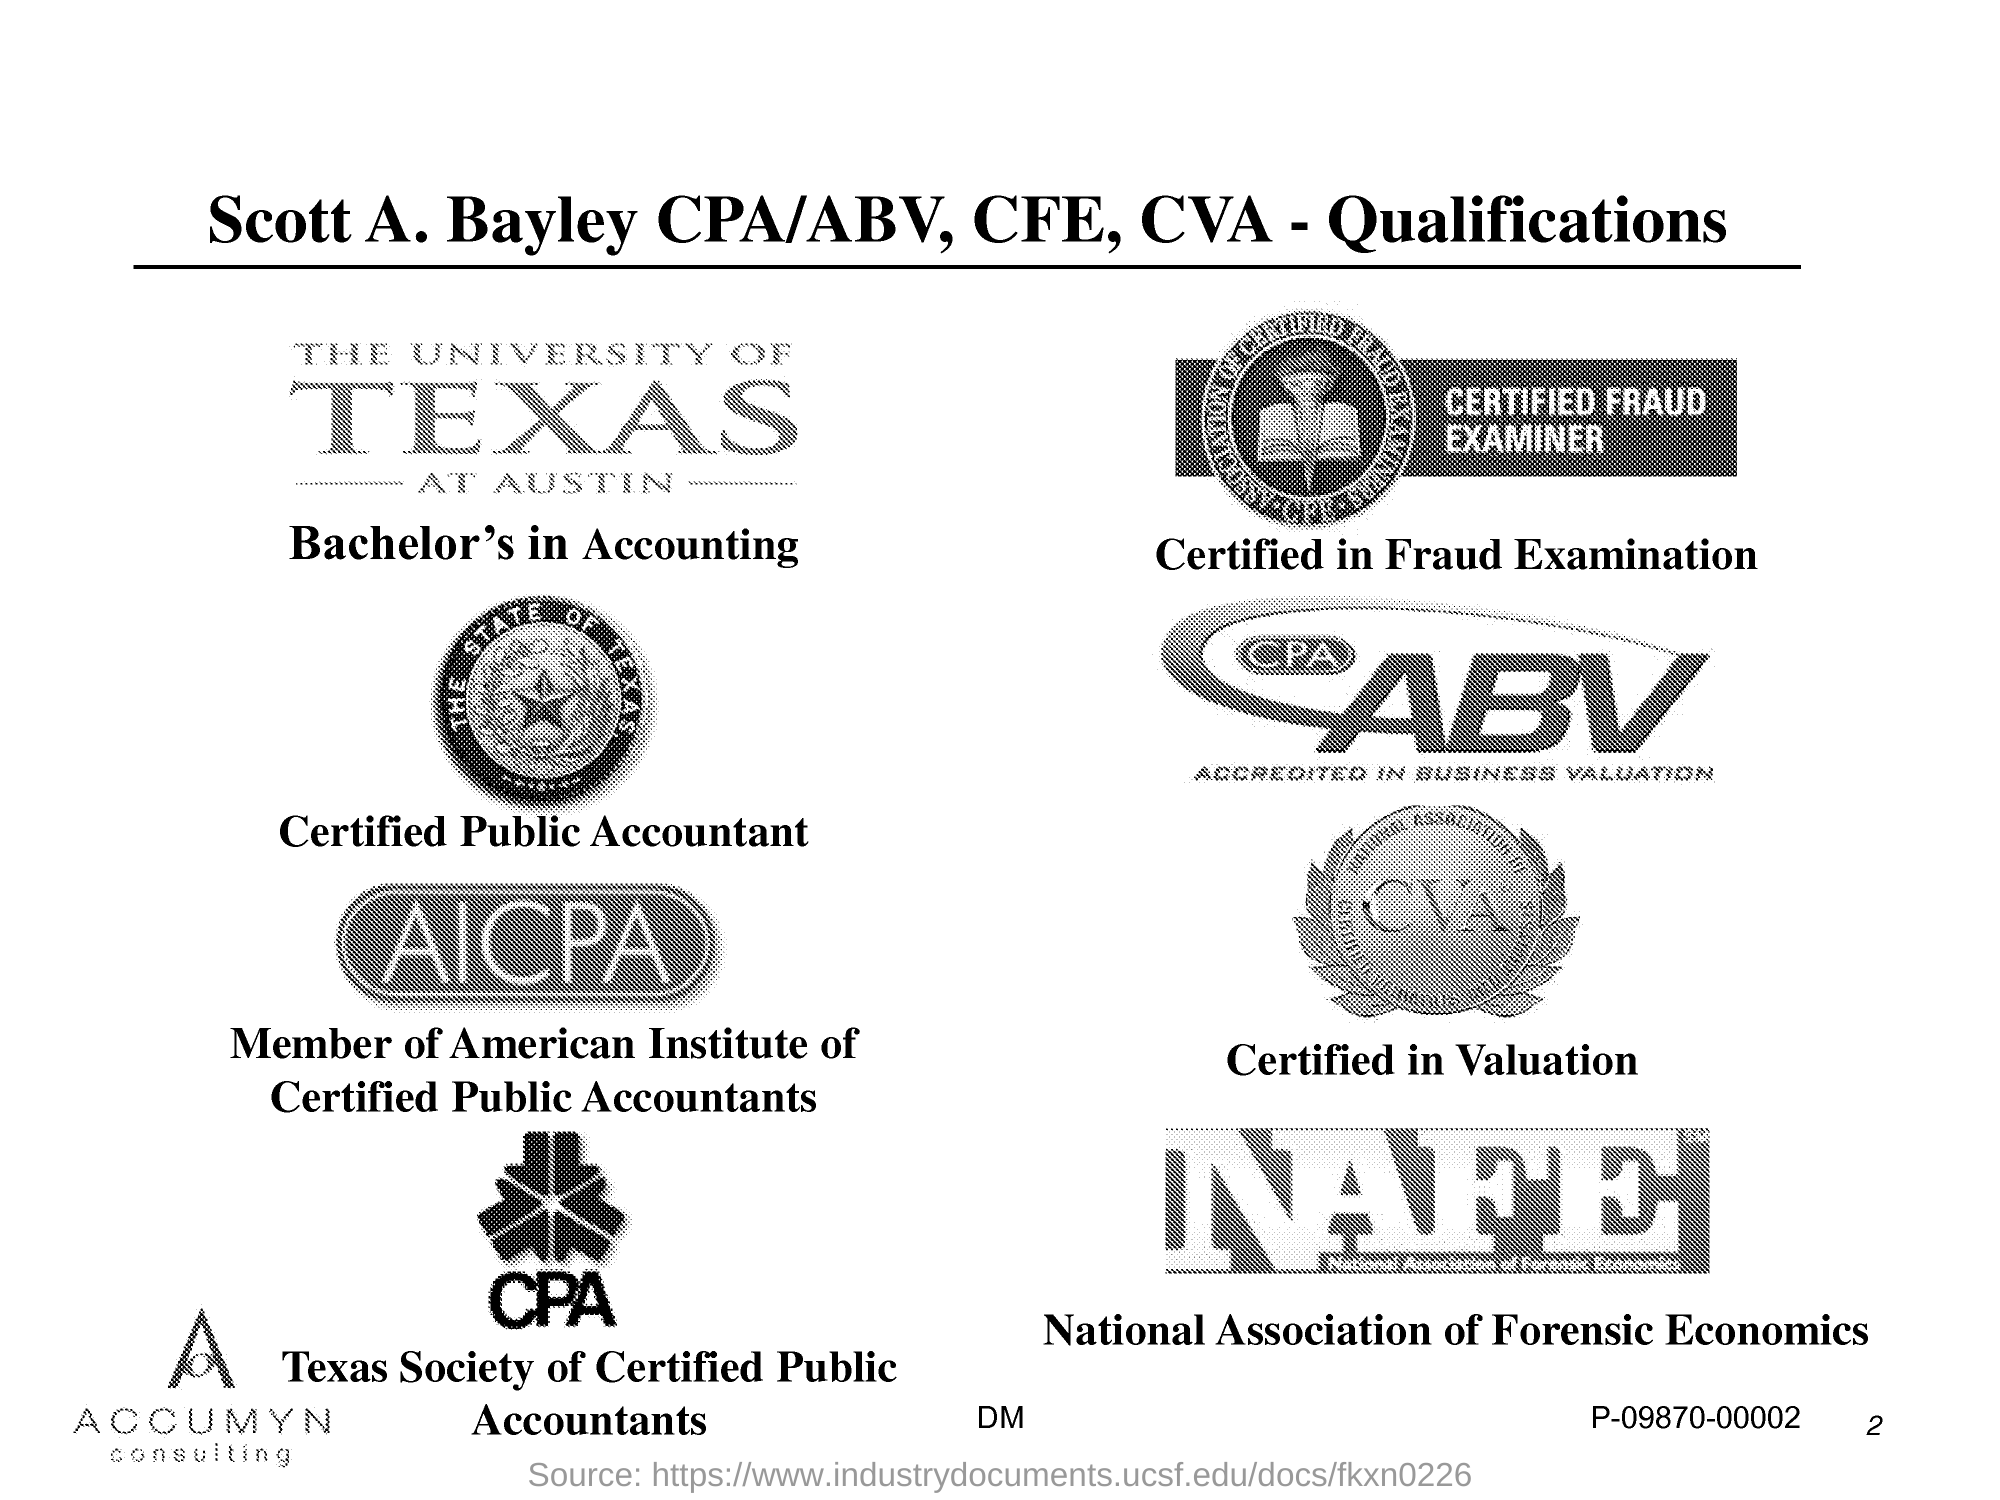Point out several critical features in this image. National Association of Forensic Economics (NAFE) is an organization dedicated to the advancement of the field of forensic economics through research, education, and professional development. 